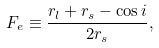Convert formula to latex. <formula><loc_0><loc_0><loc_500><loc_500>F _ { e } \equiv \frac { r _ { l } + r _ { s } - \cos { i } } { 2 r _ { s } } ,</formula> 